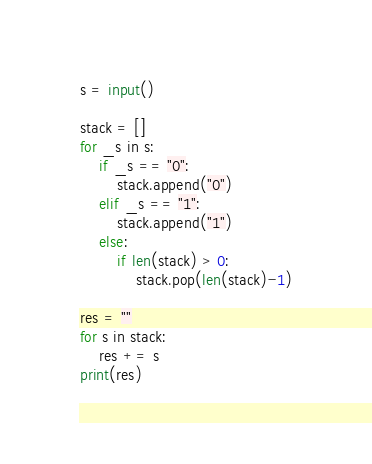Convert code to text. <code><loc_0><loc_0><loc_500><loc_500><_Python_>s = input()

stack = []
for _s in s:
    if _s == "0":
        stack.append("0")
    elif _s == "1":
        stack.append("1")
    else:
        if len(stack) > 0:
            stack.pop(len(stack)-1)

res = ""
for s in stack:
    res += s
print(res)</code> 